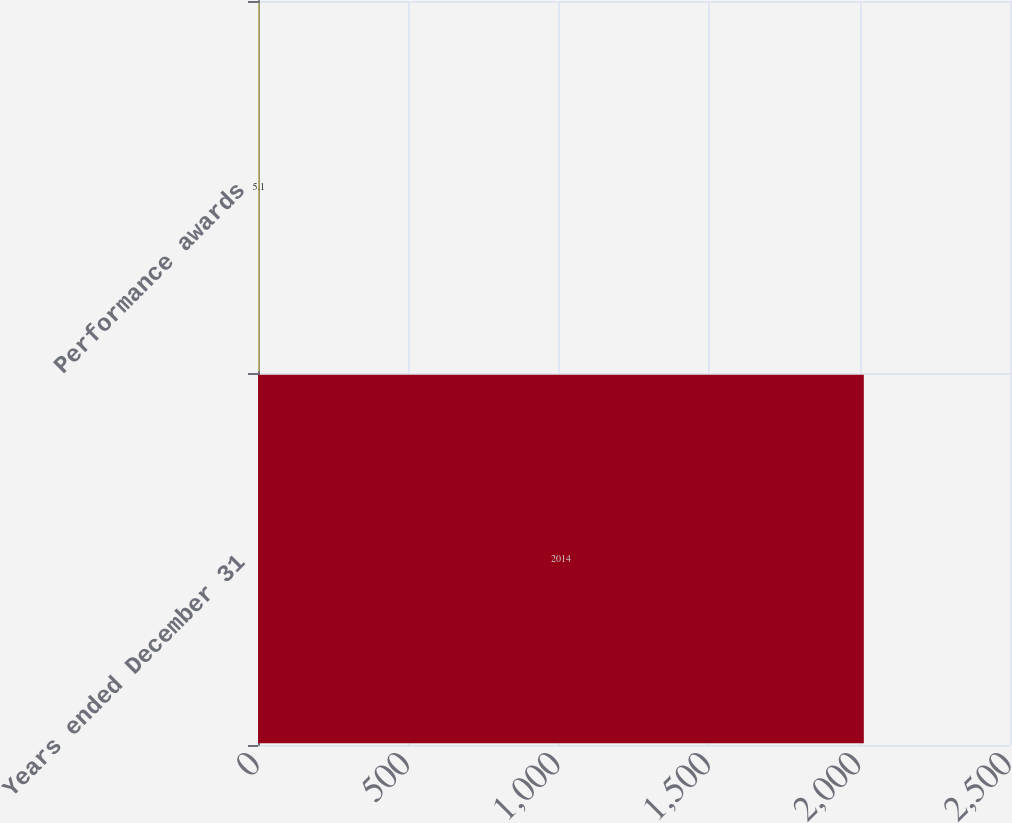Convert chart to OTSL. <chart><loc_0><loc_0><loc_500><loc_500><bar_chart><fcel>Years ended December 31<fcel>Performance awards<nl><fcel>2014<fcel>5.1<nl></chart> 